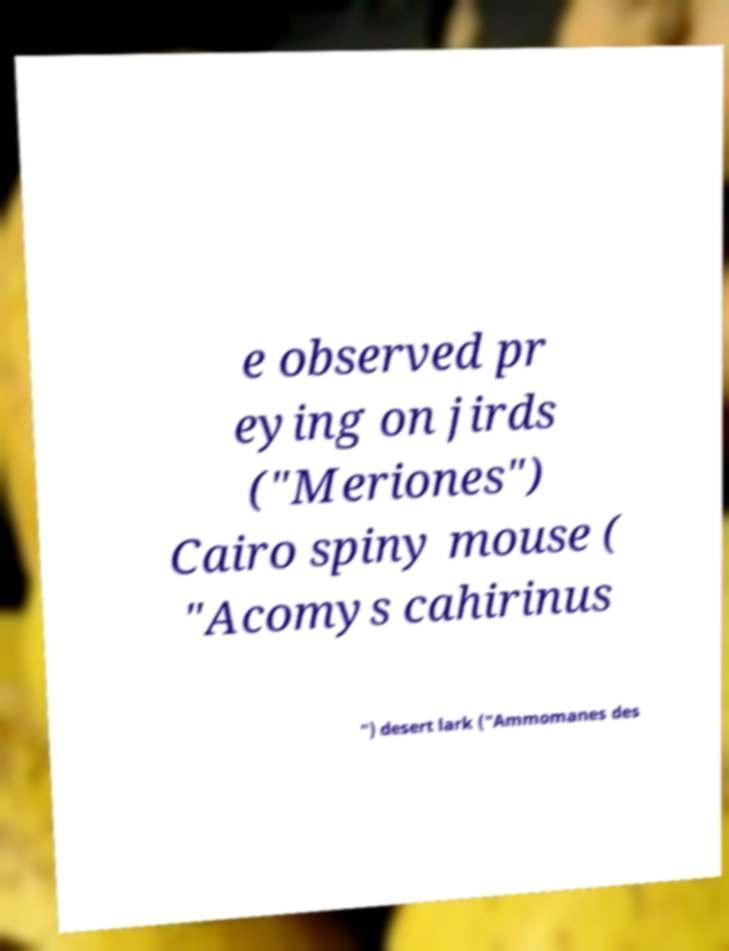Could you assist in decoding the text presented in this image and type it out clearly? e observed pr eying on jirds ("Meriones") Cairo spiny mouse ( "Acomys cahirinus ") desert lark ("Ammomanes des 